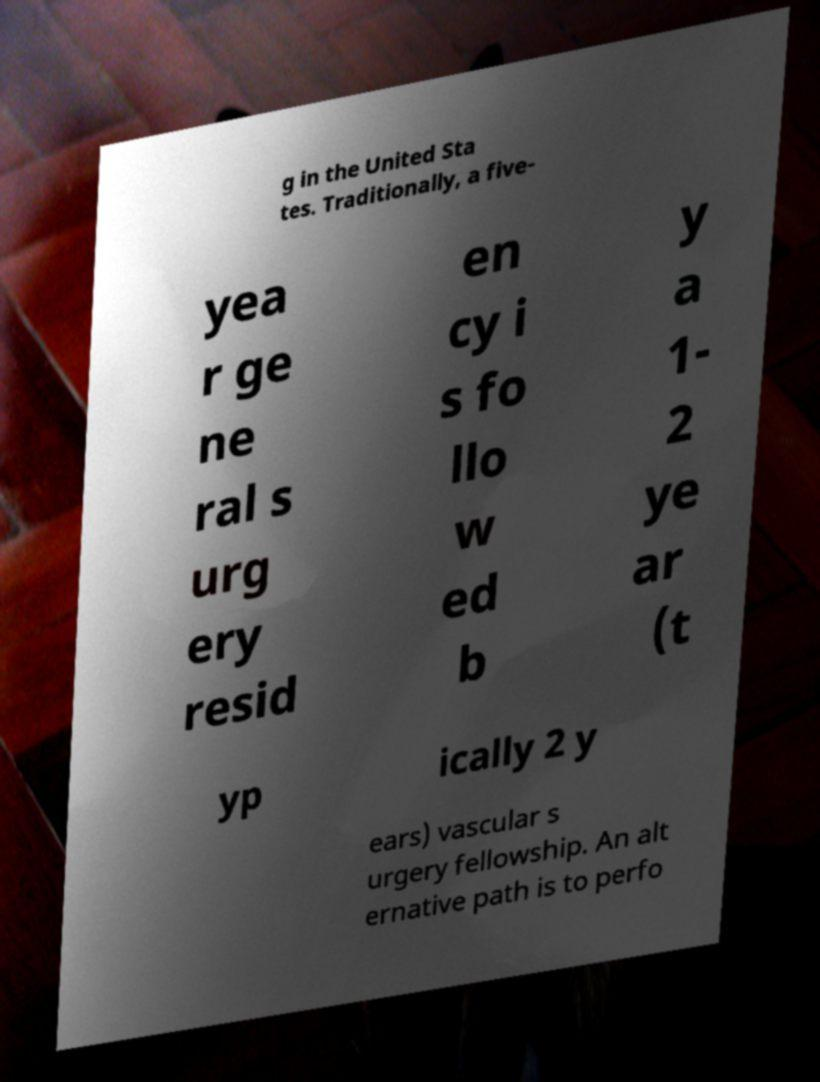Could you assist in decoding the text presented in this image and type it out clearly? g in the United Sta tes. Traditionally, a five- yea r ge ne ral s urg ery resid en cy i s fo llo w ed b y a 1- 2 ye ar (t yp ically 2 y ears) vascular s urgery fellowship. An alt ernative path is to perfo 